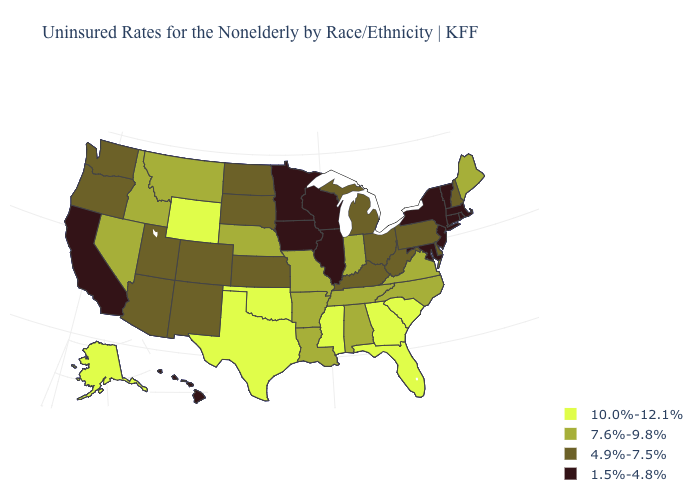Among the states that border Vermont , which have the highest value?
Give a very brief answer. New Hampshire. What is the value of Utah?
Write a very short answer. 4.9%-7.5%. Name the states that have a value in the range 7.6%-9.8%?
Write a very short answer. Alabama, Arkansas, Idaho, Indiana, Louisiana, Maine, Missouri, Montana, Nebraska, Nevada, North Carolina, Tennessee, Virginia. What is the highest value in the MidWest ?
Answer briefly. 7.6%-9.8%. Which states have the lowest value in the MidWest?
Give a very brief answer. Illinois, Iowa, Minnesota, Wisconsin. Does Florida have the highest value in the South?
Give a very brief answer. Yes. What is the lowest value in the USA?
Concise answer only. 1.5%-4.8%. What is the lowest value in the USA?
Give a very brief answer. 1.5%-4.8%. Name the states that have a value in the range 7.6%-9.8%?
Short answer required. Alabama, Arkansas, Idaho, Indiana, Louisiana, Maine, Missouri, Montana, Nebraska, Nevada, North Carolina, Tennessee, Virginia. Name the states that have a value in the range 7.6%-9.8%?
Answer briefly. Alabama, Arkansas, Idaho, Indiana, Louisiana, Maine, Missouri, Montana, Nebraska, Nevada, North Carolina, Tennessee, Virginia. What is the highest value in the USA?
Write a very short answer. 10.0%-12.1%. What is the value of Ohio?
Concise answer only. 4.9%-7.5%. Among the states that border New York , which have the highest value?
Quick response, please. Pennsylvania. Which states have the lowest value in the Northeast?
Be succinct. Connecticut, Massachusetts, New Jersey, New York, Rhode Island, Vermont. Which states have the highest value in the USA?
Be succinct. Alaska, Florida, Georgia, Mississippi, Oklahoma, South Carolina, Texas, Wyoming. 